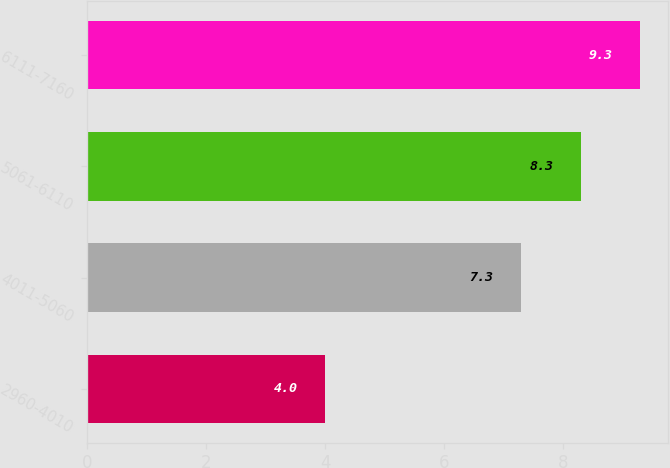Convert chart. <chart><loc_0><loc_0><loc_500><loc_500><bar_chart><fcel>2960-4010<fcel>4011-5060<fcel>5061-6110<fcel>6111-7160<nl><fcel>4<fcel>7.3<fcel>8.3<fcel>9.3<nl></chart> 